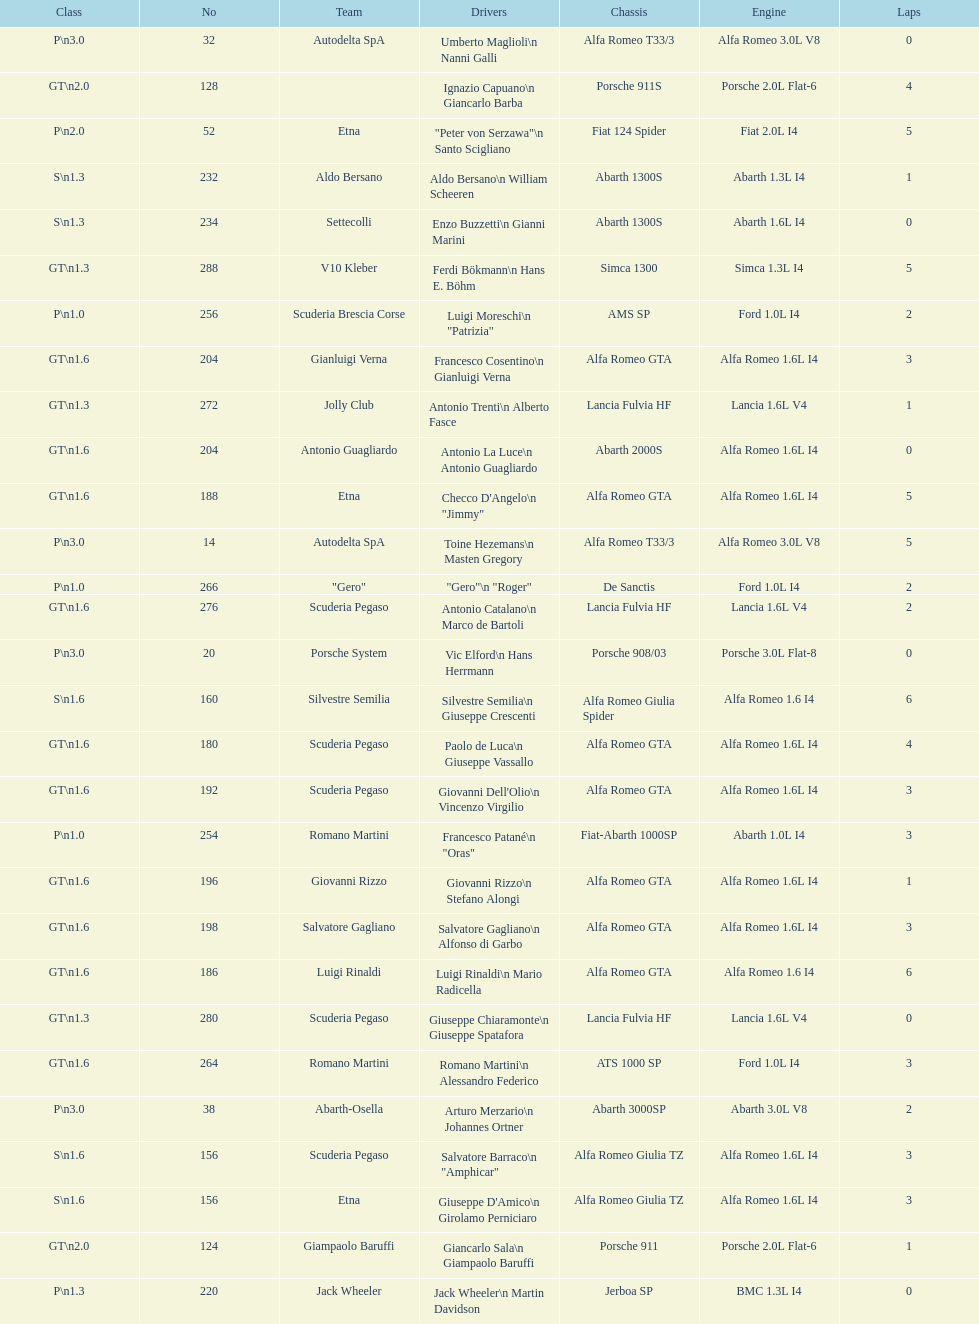What class is below s 1.6? GT 1.6. 